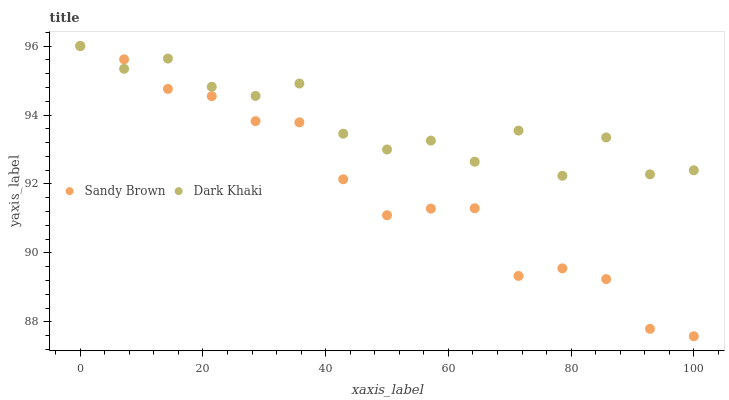Does Sandy Brown have the minimum area under the curve?
Answer yes or no. Yes. Does Dark Khaki have the maximum area under the curve?
Answer yes or no. Yes. Does Sandy Brown have the maximum area under the curve?
Answer yes or no. No. Is Sandy Brown the smoothest?
Answer yes or no. Yes. Is Dark Khaki the roughest?
Answer yes or no. Yes. Is Sandy Brown the roughest?
Answer yes or no. No. Does Sandy Brown have the lowest value?
Answer yes or no. Yes. Does Sandy Brown have the highest value?
Answer yes or no. Yes. Does Dark Khaki intersect Sandy Brown?
Answer yes or no. Yes. Is Dark Khaki less than Sandy Brown?
Answer yes or no. No. Is Dark Khaki greater than Sandy Brown?
Answer yes or no. No. 